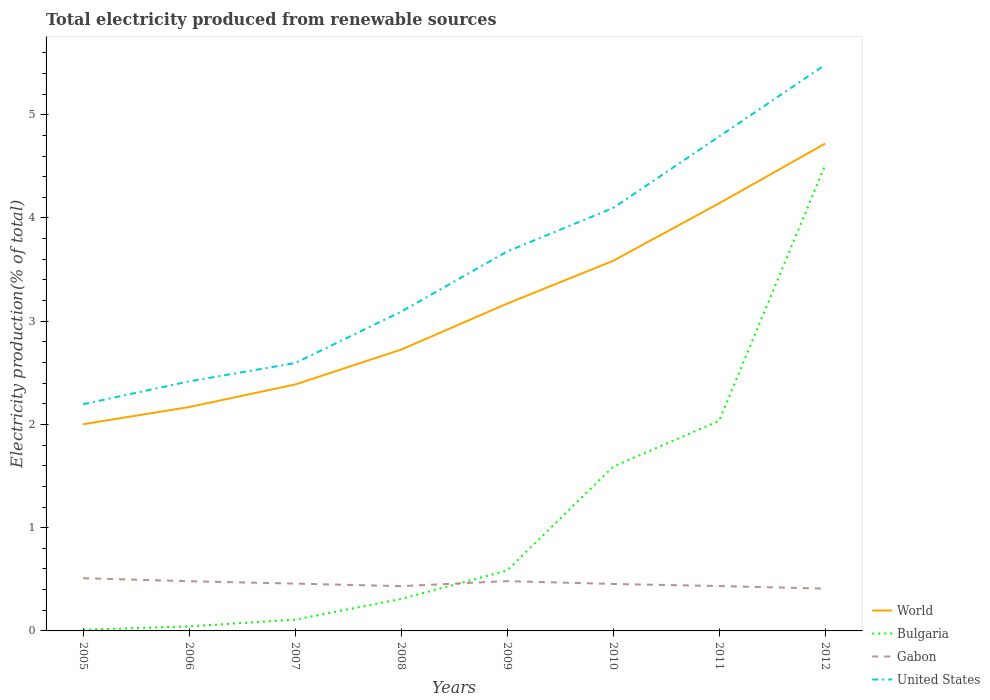Does the line corresponding to Gabon intersect with the line corresponding to World?
Provide a short and direct response. No. Is the number of lines equal to the number of legend labels?
Your response must be concise. Yes. Across all years, what is the maximum total electricity produced in Gabon?
Provide a short and direct response. 0.41. What is the total total electricity produced in Bulgaria in the graph?
Ensure brevity in your answer.  -0.2. What is the difference between the highest and the second highest total electricity produced in United States?
Your response must be concise. 3.29. What is the difference between the highest and the lowest total electricity produced in World?
Provide a succinct answer. 4. Is the total electricity produced in Gabon strictly greater than the total electricity produced in Bulgaria over the years?
Give a very brief answer. No. Are the values on the major ticks of Y-axis written in scientific E-notation?
Make the answer very short. No. Does the graph contain any zero values?
Your answer should be compact. No. How many legend labels are there?
Ensure brevity in your answer.  4. How are the legend labels stacked?
Your response must be concise. Vertical. What is the title of the graph?
Give a very brief answer. Total electricity produced from renewable sources. Does "Sub-Saharan Africa (all income levels)" appear as one of the legend labels in the graph?
Make the answer very short. No. What is the label or title of the X-axis?
Make the answer very short. Years. What is the Electricity production(% of total) of World in 2005?
Your response must be concise. 2. What is the Electricity production(% of total) in Bulgaria in 2005?
Your answer should be compact. 0.01. What is the Electricity production(% of total) of Gabon in 2005?
Your answer should be compact. 0.51. What is the Electricity production(% of total) of United States in 2005?
Offer a very short reply. 2.2. What is the Electricity production(% of total) in World in 2006?
Your response must be concise. 2.17. What is the Electricity production(% of total) in Bulgaria in 2006?
Offer a very short reply. 0.04. What is the Electricity production(% of total) in Gabon in 2006?
Provide a short and direct response. 0.48. What is the Electricity production(% of total) of United States in 2006?
Offer a very short reply. 2.42. What is the Electricity production(% of total) of World in 2007?
Provide a succinct answer. 2.39. What is the Electricity production(% of total) of Bulgaria in 2007?
Provide a short and direct response. 0.11. What is the Electricity production(% of total) in Gabon in 2007?
Your response must be concise. 0.46. What is the Electricity production(% of total) in United States in 2007?
Your answer should be very brief. 2.59. What is the Electricity production(% of total) of World in 2008?
Offer a very short reply. 2.72. What is the Electricity production(% of total) of Bulgaria in 2008?
Keep it short and to the point. 0.31. What is the Electricity production(% of total) of Gabon in 2008?
Your answer should be compact. 0.43. What is the Electricity production(% of total) in United States in 2008?
Offer a terse response. 3.09. What is the Electricity production(% of total) of World in 2009?
Give a very brief answer. 3.17. What is the Electricity production(% of total) in Bulgaria in 2009?
Provide a succinct answer. 0.59. What is the Electricity production(% of total) in Gabon in 2009?
Provide a succinct answer. 0.48. What is the Electricity production(% of total) of United States in 2009?
Your answer should be compact. 3.68. What is the Electricity production(% of total) of World in 2010?
Provide a succinct answer. 3.58. What is the Electricity production(% of total) of Bulgaria in 2010?
Ensure brevity in your answer.  1.59. What is the Electricity production(% of total) of Gabon in 2010?
Ensure brevity in your answer.  0.45. What is the Electricity production(% of total) in United States in 2010?
Give a very brief answer. 4.1. What is the Electricity production(% of total) of World in 2011?
Make the answer very short. 4.14. What is the Electricity production(% of total) in Bulgaria in 2011?
Provide a succinct answer. 2.04. What is the Electricity production(% of total) of Gabon in 2011?
Provide a short and direct response. 0.43. What is the Electricity production(% of total) in United States in 2011?
Your answer should be very brief. 4.79. What is the Electricity production(% of total) in World in 2012?
Give a very brief answer. 4.72. What is the Electricity production(% of total) in Bulgaria in 2012?
Provide a succinct answer. 4.51. What is the Electricity production(% of total) of Gabon in 2012?
Provide a succinct answer. 0.41. What is the Electricity production(% of total) in United States in 2012?
Your answer should be compact. 5.48. Across all years, what is the maximum Electricity production(% of total) of World?
Give a very brief answer. 4.72. Across all years, what is the maximum Electricity production(% of total) in Bulgaria?
Your answer should be very brief. 4.51. Across all years, what is the maximum Electricity production(% of total) in Gabon?
Your response must be concise. 0.51. Across all years, what is the maximum Electricity production(% of total) in United States?
Provide a short and direct response. 5.48. Across all years, what is the minimum Electricity production(% of total) of World?
Make the answer very short. 2. Across all years, what is the minimum Electricity production(% of total) in Bulgaria?
Offer a terse response. 0.01. Across all years, what is the minimum Electricity production(% of total) of Gabon?
Offer a very short reply. 0.41. Across all years, what is the minimum Electricity production(% of total) in United States?
Offer a terse response. 2.2. What is the total Electricity production(% of total) in World in the graph?
Offer a very short reply. 24.9. What is the total Electricity production(% of total) in Bulgaria in the graph?
Your response must be concise. 9.2. What is the total Electricity production(% of total) in Gabon in the graph?
Provide a short and direct response. 3.67. What is the total Electricity production(% of total) in United States in the graph?
Keep it short and to the point. 28.35. What is the difference between the Electricity production(% of total) of World in 2005 and that in 2006?
Your answer should be compact. -0.17. What is the difference between the Electricity production(% of total) in Bulgaria in 2005 and that in 2006?
Your response must be concise. -0.03. What is the difference between the Electricity production(% of total) of Gabon in 2005 and that in 2006?
Offer a terse response. 0.03. What is the difference between the Electricity production(% of total) in United States in 2005 and that in 2006?
Your response must be concise. -0.22. What is the difference between the Electricity production(% of total) of World in 2005 and that in 2007?
Offer a very short reply. -0.39. What is the difference between the Electricity production(% of total) in Bulgaria in 2005 and that in 2007?
Your answer should be compact. -0.1. What is the difference between the Electricity production(% of total) of Gabon in 2005 and that in 2007?
Provide a succinct answer. 0.05. What is the difference between the Electricity production(% of total) in United States in 2005 and that in 2007?
Your answer should be compact. -0.4. What is the difference between the Electricity production(% of total) in World in 2005 and that in 2008?
Provide a succinct answer. -0.72. What is the difference between the Electricity production(% of total) of Bulgaria in 2005 and that in 2008?
Provide a succinct answer. -0.3. What is the difference between the Electricity production(% of total) in Gabon in 2005 and that in 2008?
Make the answer very short. 0.08. What is the difference between the Electricity production(% of total) of United States in 2005 and that in 2008?
Your answer should be very brief. -0.9. What is the difference between the Electricity production(% of total) in World in 2005 and that in 2009?
Provide a short and direct response. -1.17. What is the difference between the Electricity production(% of total) of Bulgaria in 2005 and that in 2009?
Make the answer very short. -0.57. What is the difference between the Electricity production(% of total) in Gabon in 2005 and that in 2009?
Offer a terse response. 0.03. What is the difference between the Electricity production(% of total) of United States in 2005 and that in 2009?
Your response must be concise. -1.48. What is the difference between the Electricity production(% of total) in World in 2005 and that in 2010?
Your answer should be very brief. -1.58. What is the difference between the Electricity production(% of total) of Bulgaria in 2005 and that in 2010?
Provide a short and direct response. -1.58. What is the difference between the Electricity production(% of total) in Gabon in 2005 and that in 2010?
Keep it short and to the point. 0.06. What is the difference between the Electricity production(% of total) in United States in 2005 and that in 2010?
Ensure brevity in your answer.  -1.9. What is the difference between the Electricity production(% of total) in World in 2005 and that in 2011?
Your response must be concise. -2.14. What is the difference between the Electricity production(% of total) in Bulgaria in 2005 and that in 2011?
Your answer should be compact. -2.02. What is the difference between the Electricity production(% of total) in Gabon in 2005 and that in 2011?
Your response must be concise. 0.08. What is the difference between the Electricity production(% of total) in United States in 2005 and that in 2011?
Offer a very short reply. -2.59. What is the difference between the Electricity production(% of total) of World in 2005 and that in 2012?
Offer a very short reply. -2.72. What is the difference between the Electricity production(% of total) in Bulgaria in 2005 and that in 2012?
Offer a terse response. -4.5. What is the difference between the Electricity production(% of total) of Gabon in 2005 and that in 2012?
Your answer should be compact. 0.1. What is the difference between the Electricity production(% of total) of United States in 2005 and that in 2012?
Your answer should be compact. -3.29. What is the difference between the Electricity production(% of total) in World in 2006 and that in 2007?
Offer a terse response. -0.22. What is the difference between the Electricity production(% of total) of Bulgaria in 2006 and that in 2007?
Offer a very short reply. -0.07. What is the difference between the Electricity production(% of total) in Gabon in 2006 and that in 2007?
Keep it short and to the point. 0.02. What is the difference between the Electricity production(% of total) in United States in 2006 and that in 2007?
Provide a short and direct response. -0.18. What is the difference between the Electricity production(% of total) in World in 2006 and that in 2008?
Ensure brevity in your answer.  -0.56. What is the difference between the Electricity production(% of total) of Bulgaria in 2006 and that in 2008?
Offer a terse response. -0.27. What is the difference between the Electricity production(% of total) of Gabon in 2006 and that in 2008?
Your answer should be very brief. 0.05. What is the difference between the Electricity production(% of total) of United States in 2006 and that in 2008?
Make the answer very short. -0.68. What is the difference between the Electricity production(% of total) in World in 2006 and that in 2009?
Your answer should be compact. -1. What is the difference between the Electricity production(% of total) in Bulgaria in 2006 and that in 2009?
Keep it short and to the point. -0.54. What is the difference between the Electricity production(% of total) in Gabon in 2006 and that in 2009?
Keep it short and to the point. -0. What is the difference between the Electricity production(% of total) in United States in 2006 and that in 2009?
Offer a very short reply. -1.26. What is the difference between the Electricity production(% of total) in World in 2006 and that in 2010?
Offer a terse response. -1.42. What is the difference between the Electricity production(% of total) of Bulgaria in 2006 and that in 2010?
Your answer should be very brief. -1.55. What is the difference between the Electricity production(% of total) of Gabon in 2006 and that in 2010?
Make the answer very short. 0.03. What is the difference between the Electricity production(% of total) of United States in 2006 and that in 2010?
Provide a short and direct response. -1.68. What is the difference between the Electricity production(% of total) of World in 2006 and that in 2011?
Your answer should be compact. -1.97. What is the difference between the Electricity production(% of total) in Bulgaria in 2006 and that in 2011?
Make the answer very short. -1.99. What is the difference between the Electricity production(% of total) in Gabon in 2006 and that in 2011?
Offer a very short reply. 0.05. What is the difference between the Electricity production(% of total) of United States in 2006 and that in 2011?
Provide a short and direct response. -2.37. What is the difference between the Electricity production(% of total) in World in 2006 and that in 2012?
Provide a short and direct response. -2.55. What is the difference between the Electricity production(% of total) in Bulgaria in 2006 and that in 2012?
Your answer should be very brief. -4.47. What is the difference between the Electricity production(% of total) of Gabon in 2006 and that in 2012?
Offer a very short reply. 0.07. What is the difference between the Electricity production(% of total) in United States in 2006 and that in 2012?
Provide a short and direct response. -3.07. What is the difference between the Electricity production(% of total) in World in 2007 and that in 2008?
Keep it short and to the point. -0.34. What is the difference between the Electricity production(% of total) in Bulgaria in 2007 and that in 2008?
Your answer should be compact. -0.2. What is the difference between the Electricity production(% of total) in Gabon in 2007 and that in 2008?
Give a very brief answer. 0.02. What is the difference between the Electricity production(% of total) in United States in 2007 and that in 2008?
Give a very brief answer. -0.5. What is the difference between the Electricity production(% of total) in World in 2007 and that in 2009?
Offer a very short reply. -0.78. What is the difference between the Electricity production(% of total) of Bulgaria in 2007 and that in 2009?
Offer a terse response. -0.48. What is the difference between the Electricity production(% of total) of Gabon in 2007 and that in 2009?
Provide a short and direct response. -0.02. What is the difference between the Electricity production(% of total) of United States in 2007 and that in 2009?
Offer a very short reply. -1.08. What is the difference between the Electricity production(% of total) in World in 2007 and that in 2010?
Offer a terse response. -1.2. What is the difference between the Electricity production(% of total) of Bulgaria in 2007 and that in 2010?
Offer a very short reply. -1.48. What is the difference between the Electricity production(% of total) in Gabon in 2007 and that in 2010?
Your answer should be very brief. 0. What is the difference between the Electricity production(% of total) in United States in 2007 and that in 2010?
Offer a very short reply. -1.5. What is the difference between the Electricity production(% of total) in World in 2007 and that in 2011?
Give a very brief answer. -1.75. What is the difference between the Electricity production(% of total) in Bulgaria in 2007 and that in 2011?
Ensure brevity in your answer.  -1.93. What is the difference between the Electricity production(% of total) of Gabon in 2007 and that in 2011?
Give a very brief answer. 0.02. What is the difference between the Electricity production(% of total) of United States in 2007 and that in 2011?
Provide a short and direct response. -2.19. What is the difference between the Electricity production(% of total) of World in 2007 and that in 2012?
Offer a terse response. -2.33. What is the difference between the Electricity production(% of total) of Bulgaria in 2007 and that in 2012?
Ensure brevity in your answer.  -4.4. What is the difference between the Electricity production(% of total) of Gabon in 2007 and that in 2012?
Your answer should be compact. 0.05. What is the difference between the Electricity production(% of total) in United States in 2007 and that in 2012?
Give a very brief answer. -2.89. What is the difference between the Electricity production(% of total) in World in 2008 and that in 2009?
Offer a very short reply. -0.45. What is the difference between the Electricity production(% of total) of Bulgaria in 2008 and that in 2009?
Provide a short and direct response. -0.28. What is the difference between the Electricity production(% of total) of Gabon in 2008 and that in 2009?
Offer a terse response. -0.05. What is the difference between the Electricity production(% of total) of United States in 2008 and that in 2009?
Your answer should be compact. -0.58. What is the difference between the Electricity production(% of total) in World in 2008 and that in 2010?
Provide a short and direct response. -0.86. What is the difference between the Electricity production(% of total) of Bulgaria in 2008 and that in 2010?
Offer a terse response. -1.28. What is the difference between the Electricity production(% of total) of Gabon in 2008 and that in 2010?
Offer a very short reply. -0.02. What is the difference between the Electricity production(% of total) in United States in 2008 and that in 2010?
Offer a terse response. -1. What is the difference between the Electricity production(% of total) in World in 2008 and that in 2011?
Ensure brevity in your answer.  -1.42. What is the difference between the Electricity production(% of total) in Bulgaria in 2008 and that in 2011?
Offer a terse response. -1.73. What is the difference between the Electricity production(% of total) in Gabon in 2008 and that in 2011?
Offer a terse response. -0. What is the difference between the Electricity production(% of total) of United States in 2008 and that in 2011?
Your answer should be compact. -1.7. What is the difference between the Electricity production(% of total) in World in 2008 and that in 2012?
Offer a very short reply. -2. What is the difference between the Electricity production(% of total) in Bulgaria in 2008 and that in 2012?
Offer a very short reply. -4.2. What is the difference between the Electricity production(% of total) of Gabon in 2008 and that in 2012?
Provide a short and direct response. 0.02. What is the difference between the Electricity production(% of total) of United States in 2008 and that in 2012?
Your response must be concise. -2.39. What is the difference between the Electricity production(% of total) of World in 2009 and that in 2010?
Provide a short and direct response. -0.41. What is the difference between the Electricity production(% of total) of Bulgaria in 2009 and that in 2010?
Your answer should be very brief. -1.01. What is the difference between the Electricity production(% of total) of Gabon in 2009 and that in 2010?
Ensure brevity in your answer.  0.03. What is the difference between the Electricity production(% of total) of United States in 2009 and that in 2010?
Make the answer very short. -0.42. What is the difference between the Electricity production(% of total) of World in 2009 and that in 2011?
Provide a short and direct response. -0.97. What is the difference between the Electricity production(% of total) in Bulgaria in 2009 and that in 2011?
Your answer should be very brief. -1.45. What is the difference between the Electricity production(% of total) in Gabon in 2009 and that in 2011?
Provide a succinct answer. 0.05. What is the difference between the Electricity production(% of total) of United States in 2009 and that in 2011?
Ensure brevity in your answer.  -1.11. What is the difference between the Electricity production(% of total) in World in 2009 and that in 2012?
Give a very brief answer. -1.55. What is the difference between the Electricity production(% of total) of Bulgaria in 2009 and that in 2012?
Offer a terse response. -3.93. What is the difference between the Electricity production(% of total) in Gabon in 2009 and that in 2012?
Give a very brief answer. 0.07. What is the difference between the Electricity production(% of total) in United States in 2009 and that in 2012?
Make the answer very short. -1.81. What is the difference between the Electricity production(% of total) in World in 2010 and that in 2011?
Offer a very short reply. -0.56. What is the difference between the Electricity production(% of total) in Bulgaria in 2010 and that in 2011?
Offer a very short reply. -0.44. What is the difference between the Electricity production(% of total) of United States in 2010 and that in 2011?
Provide a short and direct response. -0.69. What is the difference between the Electricity production(% of total) of World in 2010 and that in 2012?
Your answer should be compact. -1.14. What is the difference between the Electricity production(% of total) of Bulgaria in 2010 and that in 2012?
Give a very brief answer. -2.92. What is the difference between the Electricity production(% of total) in Gabon in 2010 and that in 2012?
Your answer should be compact. 0.05. What is the difference between the Electricity production(% of total) in United States in 2010 and that in 2012?
Make the answer very short. -1.39. What is the difference between the Electricity production(% of total) of World in 2011 and that in 2012?
Provide a short and direct response. -0.58. What is the difference between the Electricity production(% of total) of Bulgaria in 2011 and that in 2012?
Offer a very short reply. -2.48. What is the difference between the Electricity production(% of total) of Gabon in 2011 and that in 2012?
Your answer should be very brief. 0.03. What is the difference between the Electricity production(% of total) in United States in 2011 and that in 2012?
Give a very brief answer. -0.69. What is the difference between the Electricity production(% of total) of World in 2005 and the Electricity production(% of total) of Bulgaria in 2006?
Offer a terse response. 1.96. What is the difference between the Electricity production(% of total) in World in 2005 and the Electricity production(% of total) in Gabon in 2006?
Offer a very short reply. 1.52. What is the difference between the Electricity production(% of total) in World in 2005 and the Electricity production(% of total) in United States in 2006?
Keep it short and to the point. -0.42. What is the difference between the Electricity production(% of total) in Bulgaria in 2005 and the Electricity production(% of total) in Gabon in 2006?
Provide a succinct answer. -0.47. What is the difference between the Electricity production(% of total) of Bulgaria in 2005 and the Electricity production(% of total) of United States in 2006?
Ensure brevity in your answer.  -2.41. What is the difference between the Electricity production(% of total) in Gabon in 2005 and the Electricity production(% of total) in United States in 2006?
Provide a short and direct response. -1.91. What is the difference between the Electricity production(% of total) in World in 2005 and the Electricity production(% of total) in Bulgaria in 2007?
Provide a succinct answer. 1.89. What is the difference between the Electricity production(% of total) of World in 2005 and the Electricity production(% of total) of Gabon in 2007?
Offer a terse response. 1.54. What is the difference between the Electricity production(% of total) of World in 2005 and the Electricity production(% of total) of United States in 2007?
Provide a succinct answer. -0.59. What is the difference between the Electricity production(% of total) of Bulgaria in 2005 and the Electricity production(% of total) of Gabon in 2007?
Offer a very short reply. -0.45. What is the difference between the Electricity production(% of total) of Bulgaria in 2005 and the Electricity production(% of total) of United States in 2007?
Provide a short and direct response. -2.58. What is the difference between the Electricity production(% of total) of Gabon in 2005 and the Electricity production(% of total) of United States in 2007?
Your response must be concise. -2.08. What is the difference between the Electricity production(% of total) in World in 2005 and the Electricity production(% of total) in Bulgaria in 2008?
Give a very brief answer. 1.69. What is the difference between the Electricity production(% of total) in World in 2005 and the Electricity production(% of total) in Gabon in 2008?
Give a very brief answer. 1.57. What is the difference between the Electricity production(% of total) in World in 2005 and the Electricity production(% of total) in United States in 2008?
Your response must be concise. -1.09. What is the difference between the Electricity production(% of total) in Bulgaria in 2005 and the Electricity production(% of total) in Gabon in 2008?
Provide a short and direct response. -0.42. What is the difference between the Electricity production(% of total) in Bulgaria in 2005 and the Electricity production(% of total) in United States in 2008?
Ensure brevity in your answer.  -3.08. What is the difference between the Electricity production(% of total) in Gabon in 2005 and the Electricity production(% of total) in United States in 2008?
Give a very brief answer. -2.58. What is the difference between the Electricity production(% of total) of World in 2005 and the Electricity production(% of total) of Bulgaria in 2009?
Make the answer very short. 1.42. What is the difference between the Electricity production(% of total) of World in 2005 and the Electricity production(% of total) of Gabon in 2009?
Your answer should be compact. 1.52. What is the difference between the Electricity production(% of total) of World in 2005 and the Electricity production(% of total) of United States in 2009?
Ensure brevity in your answer.  -1.67. What is the difference between the Electricity production(% of total) in Bulgaria in 2005 and the Electricity production(% of total) in Gabon in 2009?
Provide a succinct answer. -0.47. What is the difference between the Electricity production(% of total) of Bulgaria in 2005 and the Electricity production(% of total) of United States in 2009?
Your response must be concise. -3.66. What is the difference between the Electricity production(% of total) of Gabon in 2005 and the Electricity production(% of total) of United States in 2009?
Provide a succinct answer. -3.17. What is the difference between the Electricity production(% of total) of World in 2005 and the Electricity production(% of total) of Bulgaria in 2010?
Make the answer very short. 0.41. What is the difference between the Electricity production(% of total) of World in 2005 and the Electricity production(% of total) of Gabon in 2010?
Ensure brevity in your answer.  1.55. What is the difference between the Electricity production(% of total) of World in 2005 and the Electricity production(% of total) of United States in 2010?
Provide a succinct answer. -2.1. What is the difference between the Electricity production(% of total) of Bulgaria in 2005 and the Electricity production(% of total) of Gabon in 2010?
Offer a very short reply. -0.44. What is the difference between the Electricity production(% of total) in Bulgaria in 2005 and the Electricity production(% of total) in United States in 2010?
Give a very brief answer. -4.09. What is the difference between the Electricity production(% of total) of Gabon in 2005 and the Electricity production(% of total) of United States in 2010?
Offer a terse response. -3.59. What is the difference between the Electricity production(% of total) in World in 2005 and the Electricity production(% of total) in Bulgaria in 2011?
Make the answer very short. -0.03. What is the difference between the Electricity production(% of total) in World in 2005 and the Electricity production(% of total) in Gabon in 2011?
Your response must be concise. 1.57. What is the difference between the Electricity production(% of total) in World in 2005 and the Electricity production(% of total) in United States in 2011?
Your response must be concise. -2.79. What is the difference between the Electricity production(% of total) of Bulgaria in 2005 and the Electricity production(% of total) of Gabon in 2011?
Provide a succinct answer. -0.42. What is the difference between the Electricity production(% of total) of Bulgaria in 2005 and the Electricity production(% of total) of United States in 2011?
Your response must be concise. -4.78. What is the difference between the Electricity production(% of total) of Gabon in 2005 and the Electricity production(% of total) of United States in 2011?
Your answer should be compact. -4.28. What is the difference between the Electricity production(% of total) in World in 2005 and the Electricity production(% of total) in Bulgaria in 2012?
Provide a succinct answer. -2.51. What is the difference between the Electricity production(% of total) of World in 2005 and the Electricity production(% of total) of Gabon in 2012?
Give a very brief answer. 1.59. What is the difference between the Electricity production(% of total) in World in 2005 and the Electricity production(% of total) in United States in 2012?
Make the answer very short. -3.48. What is the difference between the Electricity production(% of total) of Bulgaria in 2005 and the Electricity production(% of total) of Gabon in 2012?
Your response must be concise. -0.4. What is the difference between the Electricity production(% of total) of Bulgaria in 2005 and the Electricity production(% of total) of United States in 2012?
Offer a terse response. -5.47. What is the difference between the Electricity production(% of total) of Gabon in 2005 and the Electricity production(% of total) of United States in 2012?
Your response must be concise. -4.97. What is the difference between the Electricity production(% of total) in World in 2006 and the Electricity production(% of total) in Bulgaria in 2007?
Your answer should be compact. 2.06. What is the difference between the Electricity production(% of total) in World in 2006 and the Electricity production(% of total) in Gabon in 2007?
Your response must be concise. 1.71. What is the difference between the Electricity production(% of total) in World in 2006 and the Electricity production(% of total) in United States in 2007?
Provide a succinct answer. -0.43. What is the difference between the Electricity production(% of total) of Bulgaria in 2006 and the Electricity production(% of total) of Gabon in 2007?
Your answer should be compact. -0.41. What is the difference between the Electricity production(% of total) of Bulgaria in 2006 and the Electricity production(% of total) of United States in 2007?
Offer a very short reply. -2.55. What is the difference between the Electricity production(% of total) in Gabon in 2006 and the Electricity production(% of total) in United States in 2007?
Offer a terse response. -2.11. What is the difference between the Electricity production(% of total) of World in 2006 and the Electricity production(% of total) of Bulgaria in 2008?
Offer a terse response. 1.86. What is the difference between the Electricity production(% of total) in World in 2006 and the Electricity production(% of total) in Gabon in 2008?
Provide a succinct answer. 1.73. What is the difference between the Electricity production(% of total) in World in 2006 and the Electricity production(% of total) in United States in 2008?
Ensure brevity in your answer.  -0.92. What is the difference between the Electricity production(% of total) of Bulgaria in 2006 and the Electricity production(% of total) of Gabon in 2008?
Offer a terse response. -0.39. What is the difference between the Electricity production(% of total) in Bulgaria in 2006 and the Electricity production(% of total) in United States in 2008?
Provide a succinct answer. -3.05. What is the difference between the Electricity production(% of total) in Gabon in 2006 and the Electricity production(% of total) in United States in 2008?
Provide a short and direct response. -2.61. What is the difference between the Electricity production(% of total) in World in 2006 and the Electricity production(% of total) in Bulgaria in 2009?
Make the answer very short. 1.58. What is the difference between the Electricity production(% of total) of World in 2006 and the Electricity production(% of total) of Gabon in 2009?
Your answer should be very brief. 1.69. What is the difference between the Electricity production(% of total) of World in 2006 and the Electricity production(% of total) of United States in 2009?
Your answer should be very brief. -1.51. What is the difference between the Electricity production(% of total) of Bulgaria in 2006 and the Electricity production(% of total) of Gabon in 2009?
Give a very brief answer. -0.44. What is the difference between the Electricity production(% of total) of Bulgaria in 2006 and the Electricity production(% of total) of United States in 2009?
Provide a short and direct response. -3.63. What is the difference between the Electricity production(% of total) of Gabon in 2006 and the Electricity production(% of total) of United States in 2009?
Make the answer very short. -3.19. What is the difference between the Electricity production(% of total) of World in 2006 and the Electricity production(% of total) of Bulgaria in 2010?
Make the answer very short. 0.58. What is the difference between the Electricity production(% of total) in World in 2006 and the Electricity production(% of total) in Gabon in 2010?
Keep it short and to the point. 1.71. What is the difference between the Electricity production(% of total) in World in 2006 and the Electricity production(% of total) in United States in 2010?
Your response must be concise. -1.93. What is the difference between the Electricity production(% of total) in Bulgaria in 2006 and the Electricity production(% of total) in Gabon in 2010?
Offer a terse response. -0.41. What is the difference between the Electricity production(% of total) of Bulgaria in 2006 and the Electricity production(% of total) of United States in 2010?
Offer a terse response. -4.05. What is the difference between the Electricity production(% of total) of Gabon in 2006 and the Electricity production(% of total) of United States in 2010?
Provide a short and direct response. -3.62. What is the difference between the Electricity production(% of total) in World in 2006 and the Electricity production(% of total) in Bulgaria in 2011?
Your response must be concise. 0.13. What is the difference between the Electricity production(% of total) in World in 2006 and the Electricity production(% of total) in Gabon in 2011?
Your answer should be compact. 1.73. What is the difference between the Electricity production(% of total) in World in 2006 and the Electricity production(% of total) in United States in 2011?
Ensure brevity in your answer.  -2.62. What is the difference between the Electricity production(% of total) in Bulgaria in 2006 and the Electricity production(% of total) in Gabon in 2011?
Your response must be concise. -0.39. What is the difference between the Electricity production(% of total) of Bulgaria in 2006 and the Electricity production(% of total) of United States in 2011?
Provide a succinct answer. -4.75. What is the difference between the Electricity production(% of total) of Gabon in 2006 and the Electricity production(% of total) of United States in 2011?
Provide a short and direct response. -4.31. What is the difference between the Electricity production(% of total) of World in 2006 and the Electricity production(% of total) of Bulgaria in 2012?
Ensure brevity in your answer.  -2.34. What is the difference between the Electricity production(% of total) of World in 2006 and the Electricity production(% of total) of Gabon in 2012?
Give a very brief answer. 1.76. What is the difference between the Electricity production(% of total) of World in 2006 and the Electricity production(% of total) of United States in 2012?
Provide a succinct answer. -3.32. What is the difference between the Electricity production(% of total) in Bulgaria in 2006 and the Electricity production(% of total) in Gabon in 2012?
Your answer should be compact. -0.37. What is the difference between the Electricity production(% of total) in Bulgaria in 2006 and the Electricity production(% of total) in United States in 2012?
Ensure brevity in your answer.  -5.44. What is the difference between the Electricity production(% of total) in Gabon in 2006 and the Electricity production(% of total) in United States in 2012?
Give a very brief answer. -5. What is the difference between the Electricity production(% of total) in World in 2007 and the Electricity production(% of total) in Bulgaria in 2008?
Offer a terse response. 2.08. What is the difference between the Electricity production(% of total) in World in 2007 and the Electricity production(% of total) in Gabon in 2008?
Give a very brief answer. 1.95. What is the difference between the Electricity production(% of total) of World in 2007 and the Electricity production(% of total) of United States in 2008?
Keep it short and to the point. -0.71. What is the difference between the Electricity production(% of total) in Bulgaria in 2007 and the Electricity production(% of total) in Gabon in 2008?
Make the answer very short. -0.32. What is the difference between the Electricity production(% of total) of Bulgaria in 2007 and the Electricity production(% of total) of United States in 2008?
Provide a succinct answer. -2.98. What is the difference between the Electricity production(% of total) of Gabon in 2007 and the Electricity production(% of total) of United States in 2008?
Offer a terse response. -2.63. What is the difference between the Electricity production(% of total) in World in 2007 and the Electricity production(% of total) in Bulgaria in 2009?
Give a very brief answer. 1.8. What is the difference between the Electricity production(% of total) of World in 2007 and the Electricity production(% of total) of Gabon in 2009?
Make the answer very short. 1.9. What is the difference between the Electricity production(% of total) in World in 2007 and the Electricity production(% of total) in United States in 2009?
Provide a succinct answer. -1.29. What is the difference between the Electricity production(% of total) of Bulgaria in 2007 and the Electricity production(% of total) of Gabon in 2009?
Provide a succinct answer. -0.37. What is the difference between the Electricity production(% of total) of Bulgaria in 2007 and the Electricity production(% of total) of United States in 2009?
Provide a succinct answer. -3.57. What is the difference between the Electricity production(% of total) in Gabon in 2007 and the Electricity production(% of total) in United States in 2009?
Provide a succinct answer. -3.22. What is the difference between the Electricity production(% of total) of World in 2007 and the Electricity production(% of total) of Bulgaria in 2010?
Keep it short and to the point. 0.8. What is the difference between the Electricity production(% of total) in World in 2007 and the Electricity production(% of total) in Gabon in 2010?
Your response must be concise. 1.93. What is the difference between the Electricity production(% of total) of World in 2007 and the Electricity production(% of total) of United States in 2010?
Keep it short and to the point. -1.71. What is the difference between the Electricity production(% of total) of Bulgaria in 2007 and the Electricity production(% of total) of Gabon in 2010?
Give a very brief answer. -0.35. What is the difference between the Electricity production(% of total) in Bulgaria in 2007 and the Electricity production(% of total) in United States in 2010?
Make the answer very short. -3.99. What is the difference between the Electricity production(% of total) of Gabon in 2007 and the Electricity production(% of total) of United States in 2010?
Your answer should be compact. -3.64. What is the difference between the Electricity production(% of total) in World in 2007 and the Electricity production(% of total) in Bulgaria in 2011?
Offer a very short reply. 0.35. What is the difference between the Electricity production(% of total) of World in 2007 and the Electricity production(% of total) of Gabon in 2011?
Your answer should be very brief. 1.95. What is the difference between the Electricity production(% of total) of World in 2007 and the Electricity production(% of total) of United States in 2011?
Your response must be concise. -2.4. What is the difference between the Electricity production(% of total) in Bulgaria in 2007 and the Electricity production(% of total) in Gabon in 2011?
Give a very brief answer. -0.33. What is the difference between the Electricity production(% of total) of Bulgaria in 2007 and the Electricity production(% of total) of United States in 2011?
Make the answer very short. -4.68. What is the difference between the Electricity production(% of total) of Gabon in 2007 and the Electricity production(% of total) of United States in 2011?
Make the answer very short. -4.33. What is the difference between the Electricity production(% of total) in World in 2007 and the Electricity production(% of total) in Bulgaria in 2012?
Keep it short and to the point. -2.12. What is the difference between the Electricity production(% of total) in World in 2007 and the Electricity production(% of total) in Gabon in 2012?
Your response must be concise. 1.98. What is the difference between the Electricity production(% of total) of World in 2007 and the Electricity production(% of total) of United States in 2012?
Your answer should be compact. -3.1. What is the difference between the Electricity production(% of total) in Bulgaria in 2007 and the Electricity production(% of total) in Gabon in 2012?
Your response must be concise. -0.3. What is the difference between the Electricity production(% of total) in Bulgaria in 2007 and the Electricity production(% of total) in United States in 2012?
Provide a short and direct response. -5.37. What is the difference between the Electricity production(% of total) of Gabon in 2007 and the Electricity production(% of total) of United States in 2012?
Your answer should be very brief. -5.03. What is the difference between the Electricity production(% of total) in World in 2008 and the Electricity production(% of total) in Bulgaria in 2009?
Your answer should be compact. 2.14. What is the difference between the Electricity production(% of total) in World in 2008 and the Electricity production(% of total) in Gabon in 2009?
Your response must be concise. 2.24. What is the difference between the Electricity production(% of total) of World in 2008 and the Electricity production(% of total) of United States in 2009?
Your answer should be very brief. -0.95. What is the difference between the Electricity production(% of total) of Bulgaria in 2008 and the Electricity production(% of total) of Gabon in 2009?
Offer a very short reply. -0.17. What is the difference between the Electricity production(% of total) of Bulgaria in 2008 and the Electricity production(% of total) of United States in 2009?
Make the answer very short. -3.37. What is the difference between the Electricity production(% of total) of Gabon in 2008 and the Electricity production(% of total) of United States in 2009?
Offer a terse response. -3.24. What is the difference between the Electricity production(% of total) of World in 2008 and the Electricity production(% of total) of Bulgaria in 2010?
Your response must be concise. 1.13. What is the difference between the Electricity production(% of total) of World in 2008 and the Electricity production(% of total) of Gabon in 2010?
Your answer should be very brief. 2.27. What is the difference between the Electricity production(% of total) in World in 2008 and the Electricity production(% of total) in United States in 2010?
Your answer should be very brief. -1.37. What is the difference between the Electricity production(% of total) of Bulgaria in 2008 and the Electricity production(% of total) of Gabon in 2010?
Make the answer very short. -0.15. What is the difference between the Electricity production(% of total) in Bulgaria in 2008 and the Electricity production(% of total) in United States in 2010?
Offer a very short reply. -3.79. What is the difference between the Electricity production(% of total) of Gabon in 2008 and the Electricity production(% of total) of United States in 2010?
Give a very brief answer. -3.66. What is the difference between the Electricity production(% of total) in World in 2008 and the Electricity production(% of total) in Bulgaria in 2011?
Your answer should be compact. 0.69. What is the difference between the Electricity production(% of total) in World in 2008 and the Electricity production(% of total) in Gabon in 2011?
Keep it short and to the point. 2.29. What is the difference between the Electricity production(% of total) of World in 2008 and the Electricity production(% of total) of United States in 2011?
Your answer should be very brief. -2.06. What is the difference between the Electricity production(% of total) of Bulgaria in 2008 and the Electricity production(% of total) of Gabon in 2011?
Keep it short and to the point. -0.13. What is the difference between the Electricity production(% of total) of Bulgaria in 2008 and the Electricity production(% of total) of United States in 2011?
Give a very brief answer. -4.48. What is the difference between the Electricity production(% of total) in Gabon in 2008 and the Electricity production(% of total) in United States in 2011?
Make the answer very short. -4.36. What is the difference between the Electricity production(% of total) in World in 2008 and the Electricity production(% of total) in Bulgaria in 2012?
Keep it short and to the point. -1.79. What is the difference between the Electricity production(% of total) of World in 2008 and the Electricity production(% of total) of Gabon in 2012?
Give a very brief answer. 2.32. What is the difference between the Electricity production(% of total) in World in 2008 and the Electricity production(% of total) in United States in 2012?
Your answer should be very brief. -2.76. What is the difference between the Electricity production(% of total) in Bulgaria in 2008 and the Electricity production(% of total) in Gabon in 2012?
Give a very brief answer. -0.1. What is the difference between the Electricity production(% of total) of Bulgaria in 2008 and the Electricity production(% of total) of United States in 2012?
Your answer should be very brief. -5.17. What is the difference between the Electricity production(% of total) of Gabon in 2008 and the Electricity production(% of total) of United States in 2012?
Give a very brief answer. -5.05. What is the difference between the Electricity production(% of total) of World in 2009 and the Electricity production(% of total) of Bulgaria in 2010?
Provide a short and direct response. 1.58. What is the difference between the Electricity production(% of total) in World in 2009 and the Electricity production(% of total) in Gabon in 2010?
Offer a very short reply. 2.72. What is the difference between the Electricity production(% of total) of World in 2009 and the Electricity production(% of total) of United States in 2010?
Provide a short and direct response. -0.93. What is the difference between the Electricity production(% of total) of Bulgaria in 2009 and the Electricity production(% of total) of Gabon in 2010?
Offer a very short reply. 0.13. What is the difference between the Electricity production(% of total) of Bulgaria in 2009 and the Electricity production(% of total) of United States in 2010?
Your answer should be very brief. -3.51. What is the difference between the Electricity production(% of total) of Gabon in 2009 and the Electricity production(% of total) of United States in 2010?
Your response must be concise. -3.61. What is the difference between the Electricity production(% of total) in World in 2009 and the Electricity production(% of total) in Bulgaria in 2011?
Give a very brief answer. 1.14. What is the difference between the Electricity production(% of total) in World in 2009 and the Electricity production(% of total) in Gabon in 2011?
Your answer should be very brief. 2.74. What is the difference between the Electricity production(% of total) in World in 2009 and the Electricity production(% of total) in United States in 2011?
Give a very brief answer. -1.62. What is the difference between the Electricity production(% of total) of Bulgaria in 2009 and the Electricity production(% of total) of Gabon in 2011?
Make the answer very short. 0.15. What is the difference between the Electricity production(% of total) in Bulgaria in 2009 and the Electricity production(% of total) in United States in 2011?
Your answer should be compact. -4.2. What is the difference between the Electricity production(% of total) of Gabon in 2009 and the Electricity production(% of total) of United States in 2011?
Give a very brief answer. -4.31. What is the difference between the Electricity production(% of total) of World in 2009 and the Electricity production(% of total) of Bulgaria in 2012?
Your answer should be very brief. -1.34. What is the difference between the Electricity production(% of total) in World in 2009 and the Electricity production(% of total) in Gabon in 2012?
Provide a short and direct response. 2.76. What is the difference between the Electricity production(% of total) in World in 2009 and the Electricity production(% of total) in United States in 2012?
Provide a short and direct response. -2.31. What is the difference between the Electricity production(% of total) of Bulgaria in 2009 and the Electricity production(% of total) of Gabon in 2012?
Ensure brevity in your answer.  0.18. What is the difference between the Electricity production(% of total) of Bulgaria in 2009 and the Electricity production(% of total) of United States in 2012?
Your answer should be compact. -4.9. What is the difference between the Electricity production(% of total) of Gabon in 2009 and the Electricity production(% of total) of United States in 2012?
Make the answer very short. -5. What is the difference between the Electricity production(% of total) in World in 2010 and the Electricity production(% of total) in Bulgaria in 2011?
Keep it short and to the point. 1.55. What is the difference between the Electricity production(% of total) in World in 2010 and the Electricity production(% of total) in Gabon in 2011?
Your response must be concise. 3.15. What is the difference between the Electricity production(% of total) in World in 2010 and the Electricity production(% of total) in United States in 2011?
Ensure brevity in your answer.  -1.2. What is the difference between the Electricity production(% of total) of Bulgaria in 2010 and the Electricity production(% of total) of Gabon in 2011?
Ensure brevity in your answer.  1.16. What is the difference between the Electricity production(% of total) in Bulgaria in 2010 and the Electricity production(% of total) in United States in 2011?
Your answer should be very brief. -3.2. What is the difference between the Electricity production(% of total) of Gabon in 2010 and the Electricity production(% of total) of United States in 2011?
Offer a very short reply. -4.33. What is the difference between the Electricity production(% of total) of World in 2010 and the Electricity production(% of total) of Bulgaria in 2012?
Ensure brevity in your answer.  -0.93. What is the difference between the Electricity production(% of total) in World in 2010 and the Electricity production(% of total) in Gabon in 2012?
Provide a succinct answer. 3.18. What is the difference between the Electricity production(% of total) of World in 2010 and the Electricity production(% of total) of United States in 2012?
Ensure brevity in your answer.  -1.9. What is the difference between the Electricity production(% of total) in Bulgaria in 2010 and the Electricity production(% of total) in Gabon in 2012?
Provide a succinct answer. 1.18. What is the difference between the Electricity production(% of total) in Bulgaria in 2010 and the Electricity production(% of total) in United States in 2012?
Keep it short and to the point. -3.89. What is the difference between the Electricity production(% of total) of Gabon in 2010 and the Electricity production(% of total) of United States in 2012?
Offer a very short reply. -5.03. What is the difference between the Electricity production(% of total) in World in 2011 and the Electricity production(% of total) in Bulgaria in 2012?
Provide a short and direct response. -0.37. What is the difference between the Electricity production(% of total) of World in 2011 and the Electricity production(% of total) of Gabon in 2012?
Your answer should be compact. 3.73. What is the difference between the Electricity production(% of total) in World in 2011 and the Electricity production(% of total) in United States in 2012?
Your answer should be compact. -1.34. What is the difference between the Electricity production(% of total) in Bulgaria in 2011 and the Electricity production(% of total) in Gabon in 2012?
Offer a very short reply. 1.63. What is the difference between the Electricity production(% of total) of Bulgaria in 2011 and the Electricity production(% of total) of United States in 2012?
Your response must be concise. -3.45. What is the difference between the Electricity production(% of total) of Gabon in 2011 and the Electricity production(% of total) of United States in 2012?
Offer a very short reply. -5.05. What is the average Electricity production(% of total) of World per year?
Give a very brief answer. 3.11. What is the average Electricity production(% of total) of Bulgaria per year?
Offer a terse response. 1.15. What is the average Electricity production(% of total) of Gabon per year?
Offer a very short reply. 0.46. What is the average Electricity production(% of total) in United States per year?
Your response must be concise. 3.54. In the year 2005, what is the difference between the Electricity production(% of total) of World and Electricity production(% of total) of Bulgaria?
Keep it short and to the point. 1.99. In the year 2005, what is the difference between the Electricity production(% of total) in World and Electricity production(% of total) in Gabon?
Ensure brevity in your answer.  1.49. In the year 2005, what is the difference between the Electricity production(% of total) in World and Electricity production(% of total) in United States?
Ensure brevity in your answer.  -0.19. In the year 2005, what is the difference between the Electricity production(% of total) of Bulgaria and Electricity production(% of total) of Gabon?
Offer a terse response. -0.5. In the year 2005, what is the difference between the Electricity production(% of total) in Bulgaria and Electricity production(% of total) in United States?
Offer a very short reply. -2.19. In the year 2005, what is the difference between the Electricity production(% of total) in Gabon and Electricity production(% of total) in United States?
Make the answer very short. -1.69. In the year 2006, what is the difference between the Electricity production(% of total) in World and Electricity production(% of total) in Bulgaria?
Keep it short and to the point. 2.12. In the year 2006, what is the difference between the Electricity production(% of total) of World and Electricity production(% of total) of Gabon?
Your answer should be very brief. 1.69. In the year 2006, what is the difference between the Electricity production(% of total) in World and Electricity production(% of total) in United States?
Your response must be concise. -0.25. In the year 2006, what is the difference between the Electricity production(% of total) in Bulgaria and Electricity production(% of total) in Gabon?
Your answer should be compact. -0.44. In the year 2006, what is the difference between the Electricity production(% of total) in Bulgaria and Electricity production(% of total) in United States?
Your response must be concise. -2.37. In the year 2006, what is the difference between the Electricity production(% of total) in Gabon and Electricity production(% of total) in United States?
Your answer should be very brief. -1.94. In the year 2007, what is the difference between the Electricity production(% of total) in World and Electricity production(% of total) in Bulgaria?
Make the answer very short. 2.28. In the year 2007, what is the difference between the Electricity production(% of total) of World and Electricity production(% of total) of Gabon?
Offer a very short reply. 1.93. In the year 2007, what is the difference between the Electricity production(% of total) of World and Electricity production(% of total) of United States?
Make the answer very short. -0.21. In the year 2007, what is the difference between the Electricity production(% of total) of Bulgaria and Electricity production(% of total) of Gabon?
Make the answer very short. -0.35. In the year 2007, what is the difference between the Electricity production(% of total) in Bulgaria and Electricity production(% of total) in United States?
Give a very brief answer. -2.49. In the year 2007, what is the difference between the Electricity production(% of total) in Gabon and Electricity production(% of total) in United States?
Ensure brevity in your answer.  -2.14. In the year 2008, what is the difference between the Electricity production(% of total) in World and Electricity production(% of total) in Bulgaria?
Keep it short and to the point. 2.42. In the year 2008, what is the difference between the Electricity production(% of total) of World and Electricity production(% of total) of Gabon?
Ensure brevity in your answer.  2.29. In the year 2008, what is the difference between the Electricity production(% of total) in World and Electricity production(% of total) in United States?
Provide a succinct answer. -0.37. In the year 2008, what is the difference between the Electricity production(% of total) in Bulgaria and Electricity production(% of total) in Gabon?
Your answer should be compact. -0.12. In the year 2008, what is the difference between the Electricity production(% of total) of Bulgaria and Electricity production(% of total) of United States?
Provide a succinct answer. -2.78. In the year 2008, what is the difference between the Electricity production(% of total) of Gabon and Electricity production(% of total) of United States?
Your answer should be compact. -2.66. In the year 2009, what is the difference between the Electricity production(% of total) of World and Electricity production(% of total) of Bulgaria?
Provide a short and direct response. 2.59. In the year 2009, what is the difference between the Electricity production(% of total) of World and Electricity production(% of total) of Gabon?
Ensure brevity in your answer.  2.69. In the year 2009, what is the difference between the Electricity production(% of total) of World and Electricity production(% of total) of United States?
Your response must be concise. -0.51. In the year 2009, what is the difference between the Electricity production(% of total) in Bulgaria and Electricity production(% of total) in Gabon?
Offer a terse response. 0.1. In the year 2009, what is the difference between the Electricity production(% of total) of Bulgaria and Electricity production(% of total) of United States?
Make the answer very short. -3.09. In the year 2009, what is the difference between the Electricity production(% of total) of Gabon and Electricity production(% of total) of United States?
Your answer should be compact. -3.19. In the year 2010, what is the difference between the Electricity production(% of total) in World and Electricity production(% of total) in Bulgaria?
Your answer should be compact. 1.99. In the year 2010, what is the difference between the Electricity production(% of total) of World and Electricity production(% of total) of Gabon?
Your response must be concise. 3.13. In the year 2010, what is the difference between the Electricity production(% of total) of World and Electricity production(% of total) of United States?
Give a very brief answer. -0.51. In the year 2010, what is the difference between the Electricity production(% of total) of Bulgaria and Electricity production(% of total) of Gabon?
Your answer should be compact. 1.14. In the year 2010, what is the difference between the Electricity production(% of total) of Bulgaria and Electricity production(% of total) of United States?
Offer a very short reply. -2.51. In the year 2010, what is the difference between the Electricity production(% of total) in Gabon and Electricity production(% of total) in United States?
Your response must be concise. -3.64. In the year 2011, what is the difference between the Electricity production(% of total) of World and Electricity production(% of total) of Bulgaria?
Your answer should be very brief. 2.11. In the year 2011, what is the difference between the Electricity production(% of total) in World and Electricity production(% of total) in Gabon?
Ensure brevity in your answer.  3.71. In the year 2011, what is the difference between the Electricity production(% of total) of World and Electricity production(% of total) of United States?
Your answer should be very brief. -0.65. In the year 2011, what is the difference between the Electricity production(% of total) in Bulgaria and Electricity production(% of total) in Gabon?
Offer a terse response. 1.6. In the year 2011, what is the difference between the Electricity production(% of total) in Bulgaria and Electricity production(% of total) in United States?
Provide a short and direct response. -2.75. In the year 2011, what is the difference between the Electricity production(% of total) in Gabon and Electricity production(% of total) in United States?
Give a very brief answer. -4.35. In the year 2012, what is the difference between the Electricity production(% of total) in World and Electricity production(% of total) in Bulgaria?
Your answer should be very brief. 0.21. In the year 2012, what is the difference between the Electricity production(% of total) in World and Electricity production(% of total) in Gabon?
Offer a very short reply. 4.31. In the year 2012, what is the difference between the Electricity production(% of total) of World and Electricity production(% of total) of United States?
Offer a terse response. -0.76. In the year 2012, what is the difference between the Electricity production(% of total) in Bulgaria and Electricity production(% of total) in Gabon?
Ensure brevity in your answer.  4.1. In the year 2012, what is the difference between the Electricity production(% of total) of Bulgaria and Electricity production(% of total) of United States?
Make the answer very short. -0.97. In the year 2012, what is the difference between the Electricity production(% of total) in Gabon and Electricity production(% of total) in United States?
Ensure brevity in your answer.  -5.07. What is the ratio of the Electricity production(% of total) in World in 2005 to that in 2006?
Offer a very short reply. 0.92. What is the ratio of the Electricity production(% of total) in Bulgaria in 2005 to that in 2006?
Offer a very short reply. 0.26. What is the ratio of the Electricity production(% of total) in Gabon in 2005 to that in 2006?
Provide a short and direct response. 1.06. What is the ratio of the Electricity production(% of total) in United States in 2005 to that in 2006?
Offer a very short reply. 0.91. What is the ratio of the Electricity production(% of total) of World in 2005 to that in 2007?
Offer a very short reply. 0.84. What is the ratio of the Electricity production(% of total) in Bulgaria in 2005 to that in 2007?
Ensure brevity in your answer.  0.1. What is the ratio of the Electricity production(% of total) of Gabon in 2005 to that in 2007?
Give a very brief answer. 1.11. What is the ratio of the Electricity production(% of total) in United States in 2005 to that in 2007?
Your answer should be compact. 0.85. What is the ratio of the Electricity production(% of total) of World in 2005 to that in 2008?
Give a very brief answer. 0.73. What is the ratio of the Electricity production(% of total) of Bulgaria in 2005 to that in 2008?
Your response must be concise. 0.04. What is the ratio of the Electricity production(% of total) in Gabon in 2005 to that in 2008?
Your answer should be very brief. 1.18. What is the ratio of the Electricity production(% of total) in United States in 2005 to that in 2008?
Make the answer very short. 0.71. What is the ratio of the Electricity production(% of total) of World in 2005 to that in 2009?
Give a very brief answer. 0.63. What is the ratio of the Electricity production(% of total) in Bulgaria in 2005 to that in 2009?
Your answer should be very brief. 0.02. What is the ratio of the Electricity production(% of total) in Gabon in 2005 to that in 2009?
Provide a short and direct response. 1.06. What is the ratio of the Electricity production(% of total) in United States in 2005 to that in 2009?
Your answer should be compact. 0.6. What is the ratio of the Electricity production(% of total) in World in 2005 to that in 2010?
Your answer should be compact. 0.56. What is the ratio of the Electricity production(% of total) in Bulgaria in 2005 to that in 2010?
Provide a short and direct response. 0.01. What is the ratio of the Electricity production(% of total) in Gabon in 2005 to that in 2010?
Provide a succinct answer. 1.12. What is the ratio of the Electricity production(% of total) in United States in 2005 to that in 2010?
Keep it short and to the point. 0.54. What is the ratio of the Electricity production(% of total) in World in 2005 to that in 2011?
Provide a succinct answer. 0.48. What is the ratio of the Electricity production(% of total) in Bulgaria in 2005 to that in 2011?
Your answer should be very brief. 0.01. What is the ratio of the Electricity production(% of total) in Gabon in 2005 to that in 2011?
Provide a short and direct response. 1.17. What is the ratio of the Electricity production(% of total) of United States in 2005 to that in 2011?
Your answer should be very brief. 0.46. What is the ratio of the Electricity production(% of total) in World in 2005 to that in 2012?
Offer a terse response. 0.42. What is the ratio of the Electricity production(% of total) of Bulgaria in 2005 to that in 2012?
Offer a terse response. 0. What is the ratio of the Electricity production(% of total) in Gabon in 2005 to that in 2012?
Your response must be concise. 1.25. What is the ratio of the Electricity production(% of total) of United States in 2005 to that in 2012?
Make the answer very short. 0.4. What is the ratio of the Electricity production(% of total) of World in 2006 to that in 2007?
Offer a terse response. 0.91. What is the ratio of the Electricity production(% of total) of Bulgaria in 2006 to that in 2007?
Offer a very short reply. 0.4. What is the ratio of the Electricity production(% of total) of Gabon in 2006 to that in 2007?
Your answer should be compact. 1.05. What is the ratio of the Electricity production(% of total) in United States in 2006 to that in 2007?
Your answer should be very brief. 0.93. What is the ratio of the Electricity production(% of total) of World in 2006 to that in 2008?
Your response must be concise. 0.8. What is the ratio of the Electricity production(% of total) of Bulgaria in 2006 to that in 2008?
Your response must be concise. 0.14. What is the ratio of the Electricity production(% of total) in Gabon in 2006 to that in 2008?
Your answer should be compact. 1.11. What is the ratio of the Electricity production(% of total) in United States in 2006 to that in 2008?
Your answer should be compact. 0.78. What is the ratio of the Electricity production(% of total) in World in 2006 to that in 2009?
Provide a succinct answer. 0.68. What is the ratio of the Electricity production(% of total) in Bulgaria in 2006 to that in 2009?
Make the answer very short. 0.08. What is the ratio of the Electricity production(% of total) in Gabon in 2006 to that in 2009?
Ensure brevity in your answer.  1. What is the ratio of the Electricity production(% of total) in United States in 2006 to that in 2009?
Ensure brevity in your answer.  0.66. What is the ratio of the Electricity production(% of total) in World in 2006 to that in 2010?
Provide a short and direct response. 0.6. What is the ratio of the Electricity production(% of total) in Bulgaria in 2006 to that in 2010?
Keep it short and to the point. 0.03. What is the ratio of the Electricity production(% of total) in Gabon in 2006 to that in 2010?
Give a very brief answer. 1.06. What is the ratio of the Electricity production(% of total) of United States in 2006 to that in 2010?
Offer a very short reply. 0.59. What is the ratio of the Electricity production(% of total) of World in 2006 to that in 2011?
Keep it short and to the point. 0.52. What is the ratio of the Electricity production(% of total) of Bulgaria in 2006 to that in 2011?
Your response must be concise. 0.02. What is the ratio of the Electricity production(% of total) of Gabon in 2006 to that in 2011?
Keep it short and to the point. 1.11. What is the ratio of the Electricity production(% of total) in United States in 2006 to that in 2011?
Provide a succinct answer. 0.5. What is the ratio of the Electricity production(% of total) in World in 2006 to that in 2012?
Give a very brief answer. 0.46. What is the ratio of the Electricity production(% of total) of Bulgaria in 2006 to that in 2012?
Provide a short and direct response. 0.01. What is the ratio of the Electricity production(% of total) in Gabon in 2006 to that in 2012?
Your answer should be compact. 1.18. What is the ratio of the Electricity production(% of total) of United States in 2006 to that in 2012?
Your answer should be very brief. 0.44. What is the ratio of the Electricity production(% of total) in World in 2007 to that in 2008?
Your answer should be very brief. 0.88. What is the ratio of the Electricity production(% of total) of Bulgaria in 2007 to that in 2008?
Offer a terse response. 0.35. What is the ratio of the Electricity production(% of total) of Gabon in 2007 to that in 2008?
Give a very brief answer. 1.06. What is the ratio of the Electricity production(% of total) of United States in 2007 to that in 2008?
Keep it short and to the point. 0.84. What is the ratio of the Electricity production(% of total) in World in 2007 to that in 2009?
Your response must be concise. 0.75. What is the ratio of the Electricity production(% of total) in Bulgaria in 2007 to that in 2009?
Make the answer very short. 0.19. What is the ratio of the Electricity production(% of total) in Gabon in 2007 to that in 2009?
Keep it short and to the point. 0.95. What is the ratio of the Electricity production(% of total) of United States in 2007 to that in 2009?
Your response must be concise. 0.71. What is the ratio of the Electricity production(% of total) of World in 2007 to that in 2010?
Give a very brief answer. 0.67. What is the ratio of the Electricity production(% of total) of Bulgaria in 2007 to that in 2010?
Keep it short and to the point. 0.07. What is the ratio of the Electricity production(% of total) of United States in 2007 to that in 2010?
Provide a succinct answer. 0.63. What is the ratio of the Electricity production(% of total) of World in 2007 to that in 2011?
Provide a short and direct response. 0.58. What is the ratio of the Electricity production(% of total) of Bulgaria in 2007 to that in 2011?
Provide a short and direct response. 0.05. What is the ratio of the Electricity production(% of total) in Gabon in 2007 to that in 2011?
Make the answer very short. 1.05. What is the ratio of the Electricity production(% of total) in United States in 2007 to that in 2011?
Provide a succinct answer. 0.54. What is the ratio of the Electricity production(% of total) of World in 2007 to that in 2012?
Keep it short and to the point. 0.51. What is the ratio of the Electricity production(% of total) of Bulgaria in 2007 to that in 2012?
Keep it short and to the point. 0.02. What is the ratio of the Electricity production(% of total) of Gabon in 2007 to that in 2012?
Offer a very short reply. 1.12. What is the ratio of the Electricity production(% of total) of United States in 2007 to that in 2012?
Give a very brief answer. 0.47. What is the ratio of the Electricity production(% of total) of World in 2008 to that in 2009?
Provide a short and direct response. 0.86. What is the ratio of the Electricity production(% of total) of Bulgaria in 2008 to that in 2009?
Keep it short and to the point. 0.53. What is the ratio of the Electricity production(% of total) in Gabon in 2008 to that in 2009?
Provide a short and direct response. 0.9. What is the ratio of the Electricity production(% of total) of United States in 2008 to that in 2009?
Provide a succinct answer. 0.84. What is the ratio of the Electricity production(% of total) of World in 2008 to that in 2010?
Keep it short and to the point. 0.76. What is the ratio of the Electricity production(% of total) of Bulgaria in 2008 to that in 2010?
Provide a short and direct response. 0.19. What is the ratio of the Electricity production(% of total) in Gabon in 2008 to that in 2010?
Your response must be concise. 0.95. What is the ratio of the Electricity production(% of total) of United States in 2008 to that in 2010?
Your answer should be very brief. 0.75. What is the ratio of the Electricity production(% of total) in World in 2008 to that in 2011?
Keep it short and to the point. 0.66. What is the ratio of the Electricity production(% of total) of Bulgaria in 2008 to that in 2011?
Ensure brevity in your answer.  0.15. What is the ratio of the Electricity production(% of total) of Gabon in 2008 to that in 2011?
Your answer should be compact. 1. What is the ratio of the Electricity production(% of total) in United States in 2008 to that in 2011?
Keep it short and to the point. 0.65. What is the ratio of the Electricity production(% of total) in World in 2008 to that in 2012?
Give a very brief answer. 0.58. What is the ratio of the Electricity production(% of total) of Bulgaria in 2008 to that in 2012?
Provide a short and direct response. 0.07. What is the ratio of the Electricity production(% of total) in Gabon in 2008 to that in 2012?
Offer a very short reply. 1.06. What is the ratio of the Electricity production(% of total) of United States in 2008 to that in 2012?
Keep it short and to the point. 0.56. What is the ratio of the Electricity production(% of total) of World in 2009 to that in 2010?
Your answer should be very brief. 0.88. What is the ratio of the Electricity production(% of total) of Bulgaria in 2009 to that in 2010?
Keep it short and to the point. 0.37. What is the ratio of the Electricity production(% of total) of Gabon in 2009 to that in 2010?
Provide a succinct answer. 1.06. What is the ratio of the Electricity production(% of total) in United States in 2009 to that in 2010?
Offer a very short reply. 0.9. What is the ratio of the Electricity production(% of total) of World in 2009 to that in 2011?
Make the answer very short. 0.77. What is the ratio of the Electricity production(% of total) of Bulgaria in 2009 to that in 2011?
Make the answer very short. 0.29. What is the ratio of the Electricity production(% of total) in Gabon in 2009 to that in 2011?
Your answer should be very brief. 1.11. What is the ratio of the Electricity production(% of total) in United States in 2009 to that in 2011?
Your response must be concise. 0.77. What is the ratio of the Electricity production(% of total) in World in 2009 to that in 2012?
Ensure brevity in your answer.  0.67. What is the ratio of the Electricity production(% of total) in Bulgaria in 2009 to that in 2012?
Provide a short and direct response. 0.13. What is the ratio of the Electricity production(% of total) in Gabon in 2009 to that in 2012?
Offer a very short reply. 1.18. What is the ratio of the Electricity production(% of total) of United States in 2009 to that in 2012?
Provide a short and direct response. 0.67. What is the ratio of the Electricity production(% of total) in World in 2010 to that in 2011?
Provide a short and direct response. 0.87. What is the ratio of the Electricity production(% of total) of Bulgaria in 2010 to that in 2011?
Provide a short and direct response. 0.78. What is the ratio of the Electricity production(% of total) of Gabon in 2010 to that in 2011?
Provide a succinct answer. 1.05. What is the ratio of the Electricity production(% of total) of United States in 2010 to that in 2011?
Offer a terse response. 0.86. What is the ratio of the Electricity production(% of total) of World in 2010 to that in 2012?
Your response must be concise. 0.76. What is the ratio of the Electricity production(% of total) in Bulgaria in 2010 to that in 2012?
Give a very brief answer. 0.35. What is the ratio of the Electricity production(% of total) of Gabon in 2010 to that in 2012?
Provide a succinct answer. 1.11. What is the ratio of the Electricity production(% of total) in United States in 2010 to that in 2012?
Give a very brief answer. 0.75. What is the ratio of the Electricity production(% of total) of World in 2011 to that in 2012?
Your response must be concise. 0.88. What is the ratio of the Electricity production(% of total) in Bulgaria in 2011 to that in 2012?
Give a very brief answer. 0.45. What is the ratio of the Electricity production(% of total) of Gabon in 2011 to that in 2012?
Ensure brevity in your answer.  1.06. What is the ratio of the Electricity production(% of total) in United States in 2011 to that in 2012?
Your answer should be very brief. 0.87. What is the difference between the highest and the second highest Electricity production(% of total) in World?
Keep it short and to the point. 0.58. What is the difference between the highest and the second highest Electricity production(% of total) in Bulgaria?
Give a very brief answer. 2.48. What is the difference between the highest and the second highest Electricity production(% of total) of Gabon?
Ensure brevity in your answer.  0.03. What is the difference between the highest and the second highest Electricity production(% of total) of United States?
Offer a terse response. 0.69. What is the difference between the highest and the lowest Electricity production(% of total) of World?
Give a very brief answer. 2.72. What is the difference between the highest and the lowest Electricity production(% of total) in Bulgaria?
Your response must be concise. 4.5. What is the difference between the highest and the lowest Electricity production(% of total) of Gabon?
Offer a very short reply. 0.1. What is the difference between the highest and the lowest Electricity production(% of total) in United States?
Make the answer very short. 3.29. 